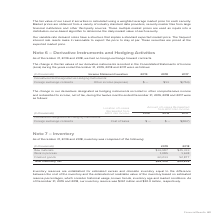According to Adtran's financial document, What was the inventory reserve in 2019? According to the financial document, $34.1 million. The relevant text states: "ember 31, 2019 and 2018, our inventory reserve was $34.1 million and $30.0 million, respectively...." Also, What was the Raw material inventory in 2019? According to the financial document, 36,987 (in thousands). The relevant text states: "Raw materials $36,987 $45,333..." Also, What was the work in process inventory in 2019? According to the financial document, 1,085 (in thousands). The relevant text states: "Work in process 1,085 1,638..." Also, can you calculate: What was the change in raw materials between 2018 and 2019? Based on the calculation: $36,987-$45,333, the result is -8346 (in thousands). This is based on the information: "Raw materials $36,987 $45,333 Raw materials $36,987 $45,333..." The key data points involved are: 36,987, 45,333. Also, can you calculate: What was the change in finished goods between 2018 and 2019? Based on the calculation: 60,233-52,877, the result is 7356 (in thousands). This is based on the information: "Finished goods 60,233 52,877 Finished goods 60,233 52,877..." The key data points involved are: 52,877, 60,233. Also, can you calculate: What was the percentage change in net total inventory between 2018 and 2019? To answer this question, I need to perform calculations using the financial data. The calculation is: ($98,305-$99,848)/$99,848, which equals -1.55 (percentage). This is based on the information: "Total Inventory, net $98,305 $99,848 Total Inventory, net $98,305 $99,848..." The key data points involved are: 98,305, 99,848. 